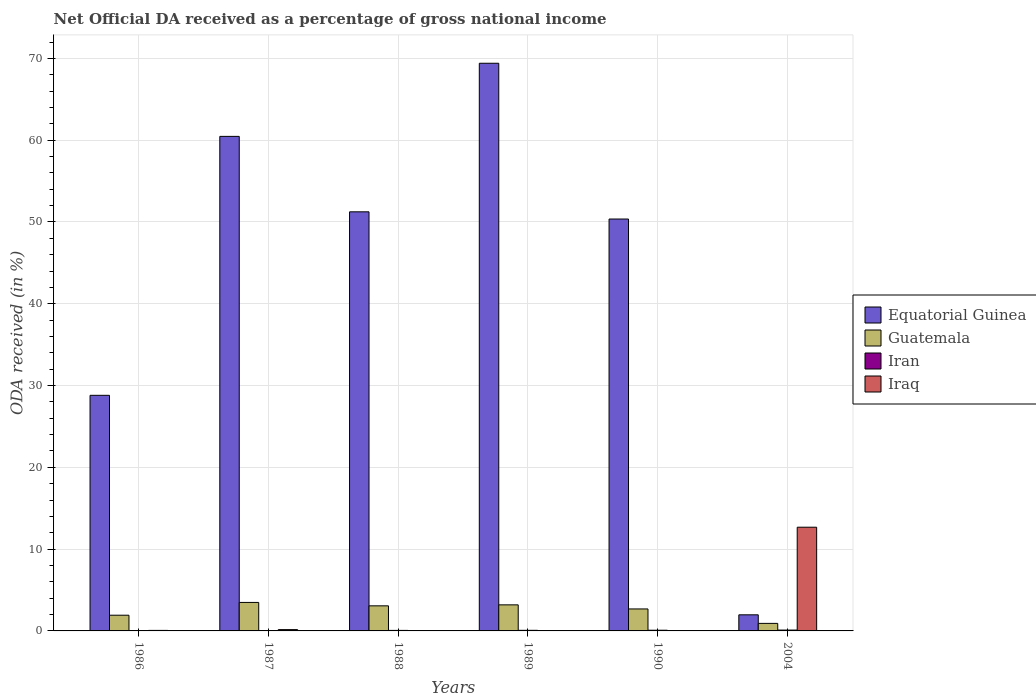How many different coloured bars are there?
Offer a terse response. 4. How many groups of bars are there?
Provide a short and direct response. 6. Are the number of bars on each tick of the X-axis equal?
Make the answer very short. Yes. How many bars are there on the 3rd tick from the left?
Your response must be concise. 4. What is the label of the 2nd group of bars from the left?
Your answer should be very brief. 1987. What is the net official DA received in Guatemala in 1986?
Your answer should be compact. 1.92. Across all years, what is the maximum net official DA received in Equatorial Guinea?
Make the answer very short. 69.4. Across all years, what is the minimum net official DA received in Guatemala?
Your response must be concise. 0.92. In which year was the net official DA received in Guatemala maximum?
Provide a succinct answer. 1987. In which year was the net official DA received in Iraq minimum?
Offer a terse response. 1988. What is the total net official DA received in Iraq in the graph?
Give a very brief answer. 12.96. What is the difference between the net official DA received in Iran in 1988 and that in 1989?
Provide a succinct answer. -0.01. What is the difference between the net official DA received in Iraq in 1988 and the net official DA received in Guatemala in 1989?
Your response must be concise. -3.18. What is the average net official DA received in Equatorial Guinea per year?
Offer a very short reply. 43.7. In the year 1989, what is the difference between the net official DA received in Iran and net official DA received in Equatorial Guinea?
Provide a succinct answer. -69.33. In how many years, is the net official DA received in Equatorial Guinea greater than 66 %?
Your answer should be compact. 1. What is the ratio of the net official DA received in Guatemala in 1987 to that in 1989?
Your response must be concise. 1.09. Is the difference between the net official DA received in Iran in 1989 and 2004 greater than the difference between the net official DA received in Equatorial Guinea in 1989 and 2004?
Offer a terse response. No. What is the difference between the highest and the second highest net official DA received in Guatemala?
Your answer should be very brief. 0.3. What is the difference between the highest and the lowest net official DA received in Equatorial Guinea?
Ensure brevity in your answer.  67.43. In how many years, is the net official DA received in Iraq greater than the average net official DA received in Iraq taken over all years?
Your response must be concise. 1. What does the 4th bar from the left in 1989 represents?
Ensure brevity in your answer.  Iraq. What does the 3rd bar from the right in 1989 represents?
Provide a short and direct response. Guatemala. Is it the case that in every year, the sum of the net official DA received in Equatorial Guinea and net official DA received in Iran is greater than the net official DA received in Iraq?
Make the answer very short. No. How many bars are there?
Your answer should be very brief. 24. Does the graph contain any zero values?
Make the answer very short. No. What is the title of the graph?
Your answer should be compact. Net Official DA received as a percentage of gross national income. Does "Dominica" appear as one of the legend labels in the graph?
Keep it short and to the point. No. What is the label or title of the Y-axis?
Your response must be concise. ODA received (in %). What is the ODA received (in %) of Equatorial Guinea in 1986?
Provide a short and direct response. 28.8. What is the ODA received (in %) in Guatemala in 1986?
Offer a terse response. 1.92. What is the ODA received (in %) in Iran in 1986?
Offer a terse response. 0.01. What is the ODA received (in %) in Iraq in 1986?
Give a very brief answer. 0.06. What is the ODA received (in %) of Equatorial Guinea in 1987?
Keep it short and to the point. 60.46. What is the ODA received (in %) of Guatemala in 1987?
Your response must be concise. 3.48. What is the ODA received (in %) in Iran in 1987?
Your answer should be very brief. 0.05. What is the ODA received (in %) in Iraq in 1987?
Keep it short and to the point. 0.16. What is the ODA received (in %) of Equatorial Guinea in 1988?
Your response must be concise. 51.24. What is the ODA received (in %) in Guatemala in 1988?
Keep it short and to the point. 3.07. What is the ODA received (in %) in Iran in 1988?
Offer a terse response. 0.06. What is the ODA received (in %) of Iraq in 1988?
Keep it short and to the point. 0.01. What is the ODA received (in %) in Equatorial Guinea in 1989?
Give a very brief answer. 69.4. What is the ODA received (in %) in Guatemala in 1989?
Ensure brevity in your answer.  3.19. What is the ODA received (in %) of Iran in 1989?
Keep it short and to the point. 0.07. What is the ODA received (in %) in Iraq in 1989?
Your answer should be compact. 0.02. What is the ODA received (in %) of Equatorial Guinea in 1990?
Give a very brief answer. 50.36. What is the ODA received (in %) in Guatemala in 1990?
Your answer should be compact. 2.69. What is the ODA received (in %) in Iran in 1990?
Offer a terse response. 0.08. What is the ODA received (in %) in Iraq in 1990?
Keep it short and to the point. 0.04. What is the ODA received (in %) in Equatorial Guinea in 2004?
Keep it short and to the point. 1.97. What is the ODA received (in %) of Guatemala in 2004?
Your answer should be very brief. 0.92. What is the ODA received (in %) in Iran in 2004?
Offer a very short reply. 0.1. What is the ODA received (in %) of Iraq in 2004?
Keep it short and to the point. 12.68. Across all years, what is the maximum ODA received (in %) in Equatorial Guinea?
Your answer should be compact. 69.4. Across all years, what is the maximum ODA received (in %) in Guatemala?
Provide a short and direct response. 3.48. Across all years, what is the maximum ODA received (in %) in Iran?
Make the answer very short. 0.1. Across all years, what is the maximum ODA received (in %) of Iraq?
Offer a very short reply. 12.68. Across all years, what is the minimum ODA received (in %) in Equatorial Guinea?
Make the answer very short. 1.97. Across all years, what is the minimum ODA received (in %) of Guatemala?
Provide a succinct answer. 0.92. Across all years, what is the minimum ODA received (in %) of Iran?
Give a very brief answer. 0.01. Across all years, what is the minimum ODA received (in %) of Iraq?
Provide a succinct answer. 0.01. What is the total ODA received (in %) of Equatorial Guinea in the graph?
Your response must be concise. 262.23. What is the total ODA received (in %) of Guatemala in the graph?
Provide a succinct answer. 15.27. What is the total ODA received (in %) of Iran in the graph?
Keep it short and to the point. 0.39. What is the total ODA received (in %) in Iraq in the graph?
Ensure brevity in your answer.  12.96. What is the difference between the ODA received (in %) in Equatorial Guinea in 1986 and that in 1987?
Ensure brevity in your answer.  -31.66. What is the difference between the ODA received (in %) of Guatemala in 1986 and that in 1987?
Your response must be concise. -1.56. What is the difference between the ODA received (in %) in Iran in 1986 and that in 1987?
Your answer should be compact. -0.04. What is the difference between the ODA received (in %) of Iraq in 1986 and that in 1987?
Keep it short and to the point. -0.1. What is the difference between the ODA received (in %) in Equatorial Guinea in 1986 and that in 1988?
Offer a terse response. -22.43. What is the difference between the ODA received (in %) of Guatemala in 1986 and that in 1988?
Your answer should be compact. -1.15. What is the difference between the ODA received (in %) of Iran in 1986 and that in 1988?
Provide a short and direct response. -0.05. What is the difference between the ODA received (in %) of Iraq in 1986 and that in 1988?
Provide a short and direct response. 0.05. What is the difference between the ODA received (in %) of Equatorial Guinea in 1986 and that in 1989?
Your answer should be compact. -40.6. What is the difference between the ODA received (in %) in Guatemala in 1986 and that in 1989?
Offer a terse response. -1.27. What is the difference between the ODA received (in %) of Iran in 1986 and that in 1989?
Give a very brief answer. -0.06. What is the difference between the ODA received (in %) in Iraq in 1986 and that in 1989?
Your answer should be very brief. 0.05. What is the difference between the ODA received (in %) of Equatorial Guinea in 1986 and that in 1990?
Offer a terse response. -21.55. What is the difference between the ODA received (in %) in Guatemala in 1986 and that in 1990?
Your answer should be compact. -0.77. What is the difference between the ODA received (in %) in Iran in 1986 and that in 1990?
Offer a very short reply. -0.07. What is the difference between the ODA received (in %) of Iraq in 1986 and that in 1990?
Provide a succinct answer. 0.03. What is the difference between the ODA received (in %) of Equatorial Guinea in 1986 and that in 2004?
Offer a very short reply. 26.84. What is the difference between the ODA received (in %) of Iran in 1986 and that in 2004?
Ensure brevity in your answer.  -0.09. What is the difference between the ODA received (in %) in Iraq in 1986 and that in 2004?
Offer a terse response. -12.62. What is the difference between the ODA received (in %) in Equatorial Guinea in 1987 and that in 1988?
Provide a succinct answer. 9.22. What is the difference between the ODA received (in %) in Guatemala in 1987 and that in 1988?
Provide a short and direct response. 0.42. What is the difference between the ODA received (in %) in Iran in 1987 and that in 1988?
Make the answer very short. -0.01. What is the difference between the ODA received (in %) in Iraq in 1987 and that in 1988?
Offer a terse response. 0.15. What is the difference between the ODA received (in %) of Equatorial Guinea in 1987 and that in 1989?
Give a very brief answer. -8.94. What is the difference between the ODA received (in %) in Guatemala in 1987 and that in 1989?
Give a very brief answer. 0.3. What is the difference between the ODA received (in %) of Iran in 1987 and that in 1989?
Provide a short and direct response. -0.02. What is the difference between the ODA received (in %) of Iraq in 1987 and that in 1989?
Ensure brevity in your answer.  0.14. What is the difference between the ODA received (in %) of Equatorial Guinea in 1987 and that in 1990?
Offer a terse response. 10.1. What is the difference between the ODA received (in %) of Guatemala in 1987 and that in 1990?
Provide a succinct answer. 0.8. What is the difference between the ODA received (in %) of Iran in 1987 and that in 1990?
Your response must be concise. -0.03. What is the difference between the ODA received (in %) of Iraq in 1987 and that in 1990?
Offer a very short reply. 0.12. What is the difference between the ODA received (in %) in Equatorial Guinea in 1987 and that in 2004?
Your answer should be very brief. 58.49. What is the difference between the ODA received (in %) in Guatemala in 1987 and that in 2004?
Ensure brevity in your answer.  2.56. What is the difference between the ODA received (in %) in Iran in 1987 and that in 2004?
Your answer should be compact. -0.05. What is the difference between the ODA received (in %) of Iraq in 1987 and that in 2004?
Give a very brief answer. -12.52. What is the difference between the ODA received (in %) of Equatorial Guinea in 1988 and that in 1989?
Make the answer very short. -18.16. What is the difference between the ODA received (in %) in Guatemala in 1988 and that in 1989?
Provide a succinct answer. -0.12. What is the difference between the ODA received (in %) of Iran in 1988 and that in 1989?
Keep it short and to the point. -0.01. What is the difference between the ODA received (in %) in Iraq in 1988 and that in 1989?
Offer a very short reply. -0.01. What is the difference between the ODA received (in %) in Equatorial Guinea in 1988 and that in 1990?
Your answer should be very brief. 0.88. What is the difference between the ODA received (in %) of Guatemala in 1988 and that in 1990?
Ensure brevity in your answer.  0.38. What is the difference between the ODA received (in %) in Iran in 1988 and that in 1990?
Provide a succinct answer. -0.02. What is the difference between the ODA received (in %) in Iraq in 1988 and that in 1990?
Your answer should be compact. -0.02. What is the difference between the ODA received (in %) in Equatorial Guinea in 1988 and that in 2004?
Ensure brevity in your answer.  49.27. What is the difference between the ODA received (in %) of Guatemala in 1988 and that in 2004?
Offer a terse response. 2.15. What is the difference between the ODA received (in %) in Iran in 1988 and that in 2004?
Keep it short and to the point. -0.04. What is the difference between the ODA received (in %) in Iraq in 1988 and that in 2004?
Your answer should be very brief. -12.67. What is the difference between the ODA received (in %) in Equatorial Guinea in 1989 and that in 1990?
Provide a short and direct response. 19.04. What is the difference between the ODA received (in %) in Guatemala in 1989 and that in 1990?
Give a very brief answer. 0.5. What is the difference between the ODA received (in %) of Iran in 1989 and that in 1990?
Make the answer very short. -0.01. What is the difference between the ODA received (in %) of Iraq in 1989 and that in 1990?
Offer a terse response. -0.02. What is the difference between the ODA received (in %) in Equatorial Guinea in 1989 and that in 2004?
Offer a terse response. 67.43. What is the difference between the ODA received (in %) of Guatemala in 1989 and that in 2004?
Provide a succinct answer. 2.27. What is the difference between the ODA received (in %) in Iran in 1989 and that in 2004?
Offer a very short reply. -0.03. What is the difference between the ODA received (in %) of Iraq in 1989 and that in 2004?
Your answer should be very brief. -12.66. What is the difference between the ODA received (in %) of Equatorial Guinea in 1990 and that in 2004?
Offer a very short reply. 48.39. What is the difference between the ODA received (in %) in Guatemala in 1990 and that in 2004?
Your response must be concise. 1.77. What is the difference between the ODA received (in %) of Iran in 1990 and that in 2004?
Make the answer very short. -0.02. What is the difference between the ODA received (in %) of Iraq in 1990 and that in 2004?
Your answer should be compact. -12.64. What is the difference between the ODA received (in %) of Equatorial Guinea in 1986 and the ODA received (in %) of Guatemala in 1987?
Your response must be concise. 25.32. What is the difference between the ODA received (in %) in Equatorial Guinea in 1986 and the ODA received (in %) in Iran in 1987?
Keep it short and to the point. 28.75. What is the difference between the ODA received (in %) in Equatorial Guinea in 1986 and the ODA received (in %) in Iraq in 1987?
Your answer should be very brief. 28.64. What is the difference between the ODA received (in %) of Guatemala in 1986 and the ODA received (in %) of Iran in 1987?
Ensure brevity in your answer.  1.87. What is the difference between the ODA received (in %) in Guatemala in 1986 and the ODA received (in %) in Iraq in 1987?
Give a very brief answer. 1.76. What is the difference between the ODA received (in %) in Iran in 1986 and the ODA received (in %) in Iraq in 1987?
Make the answer very short. -0.15. What is the difference between the ODA received (in %) of Equatorial Guinea in 1986 and the ODA received (in %) of Guatemala in 1988?
Offer a terse response. 25.74. What is the difference between the ODA received (in %) in Equatorial Guinea in 1986 and the ODA received (in %) in Iran in 1988?
Ensure brevity in your answer.  28.74. What is the difference between the ODA received (in %) in Equatorial Guinea in 1986 and the ODA received (in %) in Iraq in 1988?
Provide a short and direct response. 28.79. What is the difference between the ODA received (in %) in Guatemala in 1986 and the ODA received (in %) in Iran in 1988?
Your answer should be very brief. 1.85. What is the difference between the ODA received (in %) of Guatemala in 1986 and the ODA received (in %) of Iraq in 1988?
Offer a terse response. 1.91. What is the difference between the ODA received (in %) in Iran in 1986 and the ODA received (in %) in Iraq in 1988?
Ensure brevity in your answer.  0. What is the difference between the ODA received (in %) in Equatorial Guinea in 1986 and the ODA received (in %) in Guatemala in 1989?
Offer a very short reply. 25.62. What is the difference between the ODA received (in %) of Equatorial Guinea in 1986 and the ODA received (in %) of Iran in 1989?
Give a very brief answer. 28.73. What is the difference between the ODA received (in %) in Equatorial Guinea in 1986 and the ODA received (in %) in Iraq in 1989?
Your answer should be compact. 28.79. What is the difference between the ODA received (in %) of Guatemala in 1986 and the ODA received (in %) of Iran in 1989?
Your response must be concise. 1.85. What is the difference between the ODA received (in %) of Guatemala in 1986 and the ODA received (in %) of Iraq in 1989?
Ensure brevity in your answer.  1.9. What is the difference between the ODA received (in %) of Iran in 1986 and the ODA received (in %) of Iraq in 1989?
Your answer should be compact. -0. What is the difference between the ODA received (in %) of Equatorial Guinea in 1986 and the ODA received (in %) of Guatemala in 1990?
Your response must be concise. 26.12. What is the difference between the ODA received (in %) in Equatorial Guinea in 1986 and the ODA received (in %) in Iran in 1990?
Make the answer very short. 28.72. What is the difference between the ODA received (in %) in Equatorial Guinea in 1986 and the ODA received (in %) in Iraq in 1990?
Offer a very short reply. 28.77. What is the difference between the ODA received (in %) of Guatemala in 1986 and the ODA received (in %) of Iran in 1990?
Offer a very short reply. 1.83. What is the difference between the ODA received (in %) in Guatemala in 1986 and the ODA received (in %) in Iraq in 1990?
Keep it short and to the point. 1.88. What is the difference between the ODA received (in %) of Iran in 1986 and the ODA received (in %) of Iraq in 1990?
Give a very brief answer. -0.02. What is the difference between the ODA received (in %) of Equatorial Guinea in 1986 and the ODA received (in %) of Guatemala in 2004?
Your answer should be compact. 27.88. What is the difference between the ODA received (in %) of Equatorial Guinea in 1986 and the ODA received (in %) of Iran in 2004?
Your answer should be compact. 28.7. What is the difference between the ODA received (in %) of Equatorial Guinea in 1986 and the ODA received (in %) of Iraq in 2004?
Provide a succinct answer. 16.12. What is the difference between the ODA received (in %) of Guatemala in 1986 and the ODA received (in %) of Iran in 2004?
Offer a terse response. 1.82. What is the difference between the ODA received (in %) of Guatemala in 1986 and the ODA received (in %) of Iraq in 2004?
Your response must be concise. -10.76. What is the difference between the ODA received (in %) of Iran in 1986 and the ODA received (in %) of Iraq in 2004?
Make the answer very short. -12.67. What is the difference between the ODA received (in %) in Equatorial Guinea in 1987 and the ODA received (in %) in Guatemala in 1988?
Offer a terse response. 57.39. What is the difference between the ODA received (in %) in Equatorial Guinea in 1987 and the ODA received (in %) in Iran in 1988?
Provide a short and direct response. 60.4. What is the difference between the ODA received (in %) in Equatorial Guinea in 1987 and the ODA received (in %) in Iraq in 1988?
Your answer should be compact. 60.45. What is the difference between the ODA received (in %) of Guatemala in 1987 and the ODA received (in %) of Iran in 1988?
Offer a very short reply. 3.42. What is the difference between the ODA received (in %) in Guatemala in 1987 and the ODA received (in %) in Iraq in 1988?
Your response must be concise. 3.47. What is the difference between the ODA received (in %) in Iran in 1987 and the ODA received (in %) in Iraq in 1988?
Offer a very short reply. 0.04. What is the difference between the ODA received (in %) in Equatorial Guinea in 1987 and the ODA received (in %) in Guatemala in 1989?
Your answer should be compact. 57.27. What is the difference between the ODA received (in %) in Equatorial Guinea in 1987 and the ODA received (in %) in Iran in 1989?
Make the answer very short. 60.39. What is the difference between the ODA received (in %) of Equatorial Guinea in 1987 and the ODA received (in %) of Iraq in 1989?
Your answer should be very brief. 60.44. What is the difference between the ODA received (in %) in Guatemala in 1987 and the ODA received (in %) in Iran in 1989?
Your answer should be compact. 3.41. What is the difference between the ODA received (in %) of Guatemala in 1987 and the ODA received (in %) of Iraq in 1989?
Your answer should be very brief. 3.47. What is the difference between the ODA received (in %) in Iran in 1987 and the ODA received (in %) in Iraq in 1989?
Offer a terse response. 0.03. What is the difference between the ODA received (in %) of Equatorial Guinea in 1987 and the ODA received (in %) of Guatemala in 1990?
Offer a terse response. 57.77. What is the difference between the ODA received (in %) of Equatorial Guinea in 1987 and the ODA received (in %) of Iran in 1990?
Provide a short and direct response. 60.38. What is the difference between the ODA received (in %) of Equatorial Guinea in 1987 and the ODA received (in %) of Iraq in 1990?
Offer a very short reply. 60.42. What is the difference between the ODA received (in %) in Guatemala in 1987 and the ODA received (in %) in Iran in 1990?
Offer a terse response. 3.4. What is the difference between the ODA received (in %) in Guatemala in 1987 and the ODA received (in %) in Iraq in 1990?
Your answer should be very brief. 3.45. What is the difference between the ODA received (in %) of Iran in 1987 and the ODA received (in %) of Iraq in 1990?
Your answer should be compact. 0.02. What is the difference between the ODA received (in %) in Equatorial Guinea in 1987 and the ODA received (in %) in Guatemala in 2004?
Offer a very short reply. 59.54. What is the difference between the ODA received (in %) in Equatorial Guinea in 1987 and the ODA received (in %) in Iran in 2004?
Keep it short and to the point. 60.36. What is the difference between the ODA received (in %) in Equatorial Guinea in 1987 and the ODA received (in %) in Iraq in 2004?
Offer a terse response. 47.78. What is the difference between the ODA received (in %) of Guatemala in 1987 and the ODA received (in %) of Iran in 2004?
Ensure brevity in your answer.  3.38. What is the difference between the ODA received (in %) in Guatemala in 1987 and the ODA received (in %) in Iraq in 2004?
Give a very brief answer. -9.2. What is the difference between the ODA received (in %) in Iran in 1987 and the ODA received (in %) in Iraq in 2004?
Provide a succinct answer. -12.63. What is the difference between the ODA received (in %) in Equatorial Guinea in 1988 and the ODA received (in %) in Guatemala in 1989?
Your answer should be very brief. 48.05. What is the difference between the ODA received (in %) of Equatorial Guinea in 1988 and the ODA received (in %) of Iran in 1989?
Your response must be concise. 51.16. What is the difference between the ODA received (in %) in Equatorial Guinea in 1988 and the ODA received (in %) in Iraq in 1989?
Provide a succinct answer. 51.22. What is the difference between the ODA received (in %) of Guatemala in 1988 and the ODA received (in %) of Iran in 1989?
Provide a short and direct response. 2.99. What is the difference between the ODA received (in %) of Guatemala in 1988 and the ODA received (in %) of Iraq in 1989?
Give a very brief answer. 3.05. What is the difference between the ODA received (in %) of Iran in 1988 and the ODA received (in %) of Iraq in 1989?
Provide a succinct answer. 0.05. What is the difference between the ODA received (in %) of Equatorial Guinea in 1988 and the ODA received (in %) of Guatemala in 1990?
Your answer should be compact. 48.55. What is the difference between the ODA received (in %) in Equatorial Guinea in 1988 and the ODA received (in %) in Iran in 1990?
Provide a succinct answer. 51.15. What is the difference between the ODA received (in %) in Equatorial Guinea in 1988 and the ODA received (in %) in Iraq in 1990?
Provide a short and direct response. 51.2. What is the difference between the ODA received (in %) of Guatemala in 1988 and the ODA received (in %) of Iran in 1990?
Keep it short and to the point. 2.98. What is the difference between the ODA received (in %) in Guatemala in 1988 and the ODA received (in %) in Iraq in 1990?
Offer a terse response. 3.03. What is the difference between the ODA received (in %) in Iran in 1988 and the ODA received (in %) in Iraq in 1990?
Make the answer very short. 0.03. What is the difference between the ODA received (in %) of Equatorial Guinea in 1988 and the ODA received (in %) of Guatemala in 2004?
Offer a very short reply. 50.32. What is the difference between the ODA received (in %) in Equatorial Guinea in 1988 and the ODA received (in %) in Iran in 2004?
Your answer should be very brief. 51.13. What is the difference between the ODA received (in %) in Equatorial Guinea in 1988 and the ODA received (in %) in Iraq in 2004?
Offer a terse response. 38.56. What is the difference between the ODA received (in %) of Guatemala in 1988 and the ODA received (in %) of Iran in 2004?
Your answer should be very brief. 2.96. What is the difference between the ODA received (in %) of Guatemala in 1988 and the ODA received (in %) of Iraq in 2004?
Make the answer very short. -9.61. What is the difference between the ODA received (in %) in Iran in 1988 and the ODA received (in %) in Iraq in 2004?
Your answer should be compact. -12.61. What is the difference between the ODA received (in %) of Equatorial Guinea in 1989 and the ODA received (in %) of Guatemala in 1990?
Give a very brief answer. 66.71. What is the difference between the ODA received (in %) of Equatorial Guinea in 1989 and the ODA received (in %) of Iran in 1990?
Your response must be concise. 69.32. What is the difference between the ODA received (in %) in Equatorial Guinea in 1989 and the ODA received (in %) in Iraq in 1990?
Make the answer very short. 69.37. What is the difference between the ODA received (in %) of Guatemala in 1989 and the ODA received (in %) of Iran in 1990?
Provide a succinct answer. 3.1. What is the difference between the ODA received (in %) in Guatemala in 1989 and the ODA received (in %) in Iraq in 1990?
Offer a very short reply. 3.15. What is the difference between the ODA received (in %) of Iran in 1989 and the ODA received (in %) of Iraq in 1990?
Provide a succinct answer. 0.04. What is the difference between the ODA received (in %) of Equatorial Guinea in 1989 and the ODA received (in %) of Guatemala in 2004?
Give a very brief answer. 68.48. What is the difference between the ODA received (in %) of Equatorial Guinea in 1989 and the ODA received (in %) of Iran in 2004?
Ensure brevity in your answer.  69.3. What is the difference between the ODA received (in %) of Equatorial Guinea in 1989 and the ODA received (in %) of Iraq in 2004?
Offer a very short reply. 56.72. What is the difference between the ODA received (in %) in Guatemala in 1989 and the ODA received (in %) in Iran in 2004?
Provide a succinct answer. 3.08. What is the difference between the ODA received (in %) in Guatemala in 1989 and the ODA received (in %) in Iraq in 2004?
Ensure brevity in your answer.  -9.49. What is the difference between the ODA received (in %) in Iran in 1989 and the ODA received (in %) in Iraq in 2004?
Give a very brief answer. -12.6. What is the difference between the ODA received (in %) of Equatorial Guinea in 1990 and the ODA received (in %) of Guatemala in 2004?
Your response must be concise. 49.44. What is the difference between the ODA received (in %) in Equatorial Guinea in 1990 and the ODA received (in %) in Iran in 2004?
Offer a very short reply. 50.25. What is the difference between the ODA received (in %) in Equatorial Guinea in 1990 and the ODA received (in %) in Iraq in 2004?
Give a very brief answer. 37.68. What is the difference between the ODA received (in %) in Guatemala in 1990 and the ODA received (in %) in Iran in 2004?
Offer a very short reply. 2.58. What is the difference between the ODA received (in %) in Guatemala in 1990 and the ODA received (in %) in Iraq in 2004?
Give a very brief answer. -9.99. What is the difference between the ODA received (in %) of Iran in 1990 and the ODA received (in %) of Iraq in 2004?
Your response must be concise. -12.59. What is the average ODA received (in %) in Equatorial Guinea per year?
Keep it short and to the point. 43.7. What is the average ODA received (in %) of Guatemala per year?
Your answer should be very brief. 2.54. What is the average ODA received (in %) in Iran per year?
Provide a succinct answer. 0.07. What is the average ODA received (in %) of Iraq per year?
Keep it short and to the point. 2.16. In the year 1986, what is the difference between the ODA received (in %) of Equatorial Guinea and ODA received (in %) of Guatemala?
Your answer should be compact. 26.88. In the year 1986, what is the difference between the ODA received (in %) of Equatorial Guinea and ODA received (in %) of Iran?
Give a very brief answer. 28.79. In the year 1986, what is the difference between the ODA received (in %) in Equatorial Guinea and ODA received (in %) in Iraq?
Make the answer very short. 28.74. In the year 1986, what is the difference between the ODA received (in %) of Guatemala and ODA received (in %) of Iran?
Provide a short and direct response. 1.91. In the year 1986, what is the difference between the ODA received (in %) of Guatemala and ODA received (in %) of Iraq?
Your answer should be compact. 1.86. In the year 1986, what is the difference between the ODA received (in %) of Iran and ODA received (in %) of Iraq?
Offer a very short reply. -0.05. In the year 1987, what is the difference between the ODA received (in %) in Equatorial Guinea and ODA received (in %) in Guatemala?
Keep it short and to the point. 56.98. In the year 1987, what is the difference between the ODA received (in %) of Equatorial Guinea and ODA received (in %) of Iran?
Make the answer very short. 60.41. In the year 1987, what is the difference between the ODA received (in %) in Equatorial Guinea and ODA received (in %) in Iraq?
Provide a short and direct response. 60.3. In the year 1987, what is the difference between the ODA received (in %) of Guatemala and ODA received (in %) of Iran?
Your answer should be compact. 3.43. In the year 1987, what is the difference between the ODA received (in %) of Guatemala and ODA received (in %) of Iraq?
Your answer should be compact. 3.32. In the year 1987, what is the difference between the ODA received (in %) in Iran and ODA received (in %) in Iraq?
Offer a very short reply. -0.11. In the year 1988, what is the difference between the ODA received (in %) of Equatorial Guinea and ODA received (in %) of Guatemala?
Offer a terse response. 48.17. In the year 1988, what is the difference between the ODA received (in %) in Equatorial Guinea and ODA received (in %) in Iran?
Offer a very short reply. 51.17. In the year 1988, what is the difference between the ODA received (in %) in Equatorial Guinea and ODA received (in %) in Iraq?
Your answer should be compact. 51.23. In the year 1988, what is the difference between the ODA received (in %) of Guatemala and ODA received (in %) of Iran?
Offer a very short reply. 3. In the year 1988, what is the difference between the ODA received (in %) of Guatemala and ODA received (in %) of Iraq?
Give a very brief answer. 3.06. In the year 1988, what is the difference between the ODA received (in %) in Iran and ODA received (in %) in Iraq?
Your answer should be very brief. 0.05. In the year 1989, what is the difference between the ODA received (in %) in Equatorial Guinea and ODA received (in %) in Guatemala?
Keep it short and to the point. 66.21. In the year 1989, what is the difference between the ODA received (in %) of Equatorial Guinea and ODA received (in %) of Iran?
Make the answer very short. 69.33. In the year 1989, what is the difference between the ODA received (in %) in Equatorial Guinea and ODA received (in %) in Iraq?
Offer a terse response. 69.38. In the year 1989, what is the difference between the ODA received (in %) in Guatemala and ODA received (in %) in Iran?
Offer a terse response. 3.11. In the year 1989, what is the difference between the ODA received (in %) of Guatemala and ODA received (in %) of Iraq?
Provide a short and direct response. 3.17. In the year 1989, what is the difference between the ODA received (in %) in Iran and ODA received (in %) in Iraq?
Your answer should be compact. 0.06. In the year 1990, what is the difference between the ODA received (in %) of Equatorial Guinea and ODA received (in %) of Guatemala?
Your response must be concise. 47.67. In the year 1990, what is the difference between the ODA received (in %) in Equatorial Guinea and ODA received (in %) in Iran?
Provide a short and direct response. 50.27. In the year 1990, what is the difference between the ODA received (in %) in Equatorial Guinea and ODA received (in %) in Iraq?
Ensure brevity in your answer.  50.32. In the year 1990, what is the difference between the ODA received (in %) in Guatemala and ODA received (in %) in Iran?
Provide a succinct answer. 2.6. In the year 1990, what is the difference between the ODA received (in %) of Guatemala and ODA received (in %) of Iraq?
Provide a succinct answer. 2.65. In the year 1990, what is the difference between the ODA received (in %) in Iran and ODA received (in %) in Iraq?
Offer a very short reply. 0.05. In the year 2004, what is the difference between the ODA received (in %) of Equatorial Guinea and ODA received (in %) of Guatemala?
Give a very brief answer. 1.05. In the year 2004, what is the difference between the ODA received (in %) in Equatorial Guinea and ODA received (in %) in Iran?
Offer a very short reply. 1.86. In the year 2004, what is the difference between the ODA received (in %) of Equatorial Guinea and ODA received (in %) of Iraq?
Offer a terse response. -10.71. In the year 2004, what is the difference between the ODA received (in %) in Guatemala and ODA received (in %) in Iran?
Offer a terse response. 0.82. In the year 2004, what is the difference between the ODA received (in %) of Guatemala and ODA received (in %) of Iraq?
Your response must be concise. -11.76. In the year 2004, what is the difference between the ODA received (in %) in Iran and ODA received (in %) in Iraq?
Make the answer very short. -12.57. What is the ratio of the ODA received (in %) in Equatorial Guinea in 1986 to that in 1987?
Give a very brief answer. 0.48. What is the ratio of the ODA received (in %) in Guatemala in 1986 to that in 1987?
Provide a short and direct response. 0.55. What is the ratio of the ODA received (in %) of Iran in 1986 to that in 1987?
Offer a very short reply. 0.24. What is the ratio of the ODA received (in %) in Iraq in 1986 to that in 1987?
Make the answer very short. 0.4. What is the ratio of the ODA received (in %) of Equatorial Guinea in 1986 to that in 1988?
Provide a short and direct response. 0.56. What is the ratio of the ODA received (in %) of Guatemala in 1986 to that in 1988?
Your answer should be compact. 0.63. What is the ratio of the ODA received (in %) in Iran in 1986 to that in 1988?
Give a very brief answer. 0.19. What is the ratio of the ODA received (in %) of Iraq in 1986 to that in 1988?
Offer a terse response. 5.84. What is the ratio of the ODA received (in %) in Equatorial Guinea in 1986 to that in 1989?
Keep it short and to the point. 0.41. What is the ratio of the ODA received (in %) in Guatemala in 1986 to that in 1989?
Give a very brief answer. 0.6. What is the ratio of the ODA received (in %) in Iran in 1986 to that in 1989?
Your response must be concise. 0.17. What is the ratio of the ODA received (in %) of Iraq in 1986 to that in 1989?
Offer a very short reply. 3.67. What is the ratio of the ODA received (in %) in Equatorial Guinea in 1986 to that in 1990?
Your answer should be very brief. 0.57. What is the ratio of the ODA received (in %) of Guatemala in 1986 to that in 1990?
Give a very brief answer. 0.71. What is the ratio of the ODA received (in %) in Iran in 1986 to that in 1990?
Ensure brevity in your answer.  0.14. What is the ratio of the ODA received (in %) in Iraq in 1986 to that in 1990?
Offer a very short reply. 1.77. What is the ratio of the ODA received (in %) in Equatorial Guinea in 1986 to that in 2004?
Provide a short and direct response. 14.64. What is the ratio of the ODA received (in %) of Guatemala in 1986 to that in 2004?
Keep it short and to the point. 2.08. What is the ratio of the ODA received (in %) in Iran in 1986 to that in 2004?
Give a very brief answer. 0.12. What is the ratio of the ODA received (in %) of Iraq in 1986 to that in 2004?
Give a very brief answer. 0.01. What is the ratio of the ODA received (in %) in Equatorial Guinea in 1987 to that in 1988?
Your answer should be very brief. 1.18. What is the ratio of the ODA received (in %) in Guatemala in 1987 to that in 1988?
Provide a short and direct response. 1.14. What is the ratio of the ODA received (in %) in Iran in 1987 to that in 1988?
Make the answer very short. 0.79. What is the ratio of the ODA received (in %) of Iraq in 1987 to that in 1988?
Offer a very short reply. 14.73. What is the ratio of the ODA received (in %) of Equatorial Guinea in 1987 to that in 1989?
Your response must be concise. 0.87. What is the ratio of the ODA received (in %) of Guatemala in 1987 to that in 1989?
Give a very brief answer. 1.09. What is the ratio of the ODA received (in %) in Iran in 1987 to that in 1989?
Provide a succinct answer. 0.69. What is the ratio of the ODA received (in %) in Iraq in 1987 to that in 1989?
Your response must be concise. 9.27. What is the ratio of the ODA received (in %) of Equatorial Guinea in 1987 to that in 1990?
Your response must be concise. 1.2. What is the ratio of the ODA received (in %) in Guatemala in 1987 to that in 1990?
Your response must be concise. 1.3. What is the ratio of the ODA received (in %) of Iran in 1987 to that in 1990?
Make the answer very short. 0.61. What is the ratio of the ODA received (in %) in Iraq in 1987 to that in 1990?
Offer a very short reply. 4.46. What is the ratio of the ODA received (in %) in Equatorial Guinea in 1987 to that in 2004?
Keep it short and to the point. 30.73. What is the ratio of the ODA received (in %) of Guatemala in 1987 to that in 2004?
Your answer should be compact. 3.78. What is the ratio of the ODA received (in %) of Iran in 1987 to that in 2004?
Offer a terse response. 0.49. What is the ratio of the ODA received (in %) in Iraq in 1987 to that in 2004?
Provide a short and direct response. 0.01. What is the ratio of the ODA received (in %) in Equatorial Guinea in 1988 to that in 1989?
Your answer should be compact. 0.74. What is the ratio of the ODA received (in %) of Guatemala in 1988 to that in 1989?
Provide a succinct answer. 0.96. What is the ratio of the ODA received (in %) of Iran in 1988 to that in 1989?
Provide a short and direct response. 0.87. What is the ratio of the ODA received (in %) in Iraq in 1988 to that in 1989?
Offer a terse response. 0.63. What is the ratio of the ODA received (in %) in Equatorial Guinea in 1988 to that in 1990?
Provide a short and direct response. 1.02. What is the ratio of the ODA received (in %) of Guatemala in 1988 to that in 1990?
Give a very brief answer. 1.14. What is the ratio of the ODA received (in %) in Iran in 1988 to that in 1990?
Offer a very short reply. 0.76. What is the ratio of the ODA received (in %) of Iraq in 1988 to that in 1990?
Provide a short and direct response. 0.3. What is the ratio of the ODA received (in %) of Equatorial Guinea in 1988 to that in 2004?
Your response must be concise. 26.04. What is the ratio of the ODA received (in %) of Guatemala in 1988 to that in 2004?
Your answer should be compact. 3.33. What is the ratio of the ODA received (in %) in Iran in 1988 to that in 2004?
Provide a short and direct response. 0.62. What is the ratio of the ODA received (in %) in Iraq in 1988 to that in 2004?
Offer a terse response. 0. What is the ratio of the ODA received (in %) of Equatorial Guinea in 1989 to that in 1990?
Keep it short and to the point. 1.38. What is the ratio of the ODA received (in %) of Guatemala in 1989 to that in 1990?
Offer a terse response. 1.19. What is the ratio of the ODA received (in %) of Iran in 1989 to that in 1990?
Keep it short and to the point. 0.87. What is the ratio of the ODA received (in %) of Iraq in 1989 to that in 1990?
Make the answer very short. 0.48. What is the ratio of the ODA received (in %) of Equatorial Guinea in 1989 to that in 2004?
Make the answer very short. 35.27. What is the ratio of the ODA received (in %) in Guatemala in 1989 to that in 2004?
Your response must be concise. 3.46. What is the ratio of the ODA received (in %) of Iran in 1989 to that in 2004?
Keep it short and to the point. 0.71. What is the ratio of the ODA received (in %) of Iraq in 1989 to that in 2004?
Ensure brevity in your answer.  0. What is the ratio of the ODA received (in %) of Equatorial Guinea in 1990 to that in 2004?
Ensure brevity in your answer.  25.59. What is the ratio of the ODA received (in %) of Guatemala in 1990 to that in 2004?
Offer a terse response. 2.92. What is the ratio of the ODA received (in %) of Iran in 1990 to that in 2004?
Your answer should be very brief. 0.82. What is the ratio of the ODA received (in %) of Iraq in 1990 to that in 2004?
Ensure brevity in your answer.  0. What is the difference between the highest and the second highest ODA received (in %) of Equatorial Guinea?
Offer a very short reply. 8.94. What is the difference between the highest and the second highest ODA received (in %) in Guatemala?
Your answer should be compact. 0.3. What is the difference between the highest and the second highest ODA received (in %) in Iran?
Your response must be concise. 0.02. What is the difference between the highest and the second highest ODA received (in %) in Iraq?
Your response must be concise. 12.52. What is the difference between the highest and the lowest ODA received (in %) in Equatorial Guinea?
Keep it short and to the point. 67.43. What is the difference between the highest and the lowest ODA received (in %) of Guatemala?
Your response must be concise. 2.56. What is the difference between the highest and the lowest ODA received (in %) in Iran?
Your answer should be compact. 0.09. What is the difference between the highest and the lowest ODA received (in %) in Iraq?
Provide a succinct answer. 12.67. 